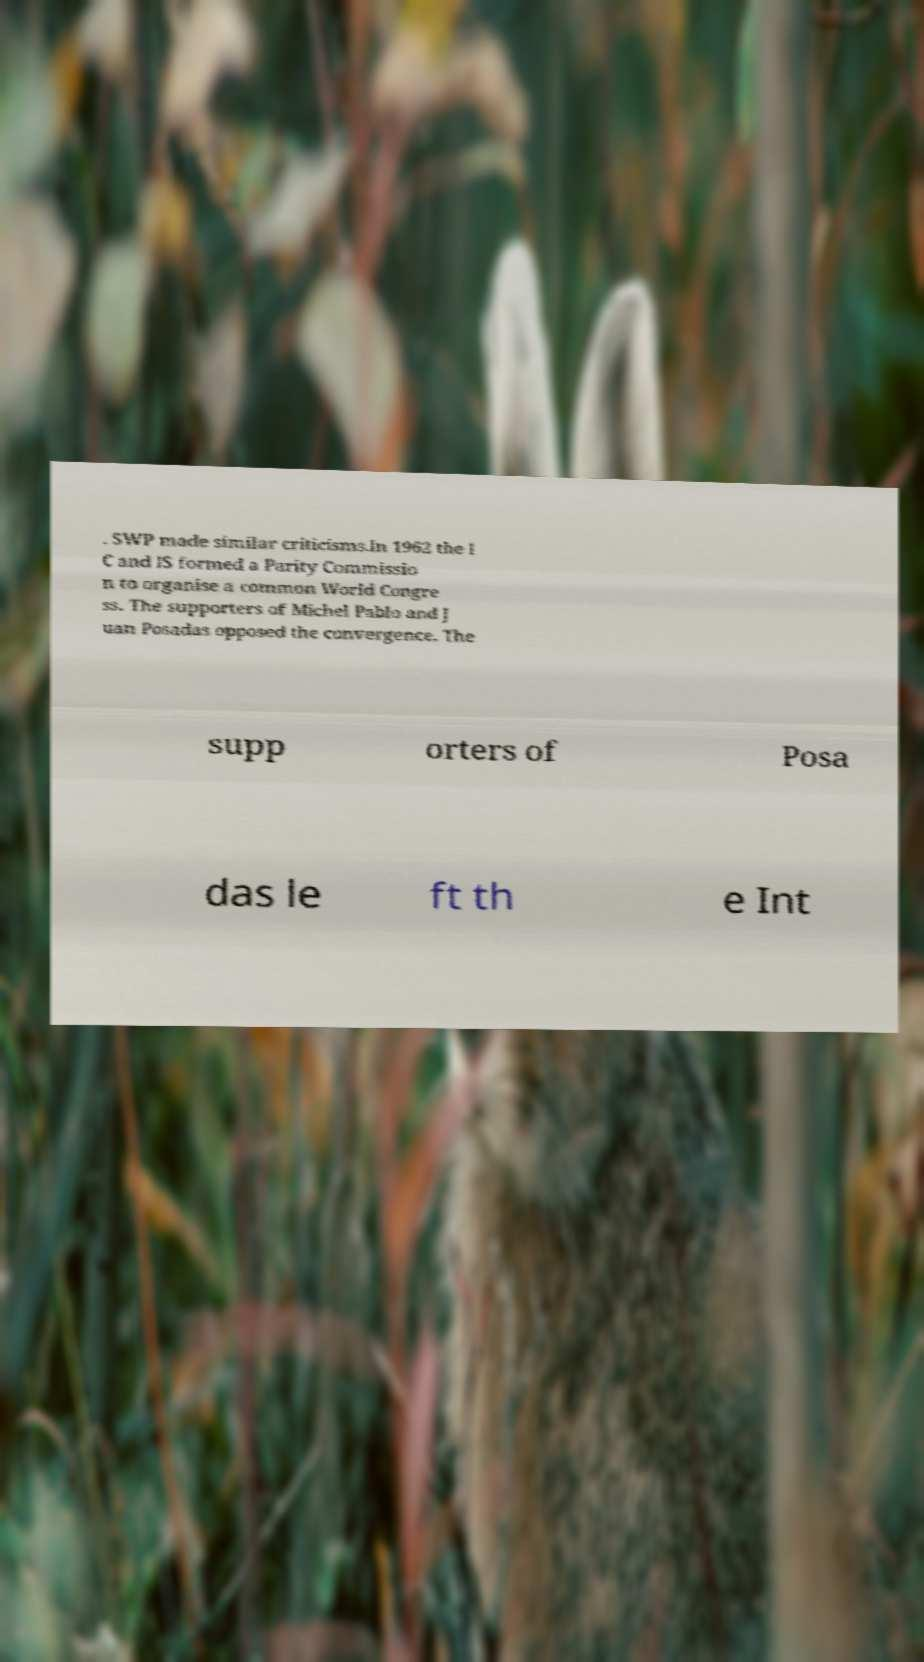Could you assist in decoding the text presented in this image and type it out clearly? . SWP made similar criticisms.In 1962 the I C and IS formed a Parity Commissio n to organise a common World Congre ss. The supporters of Michel Pablo and J uan Posadas opposed the convergence. The supp orters of Posa das le ft th e Int 